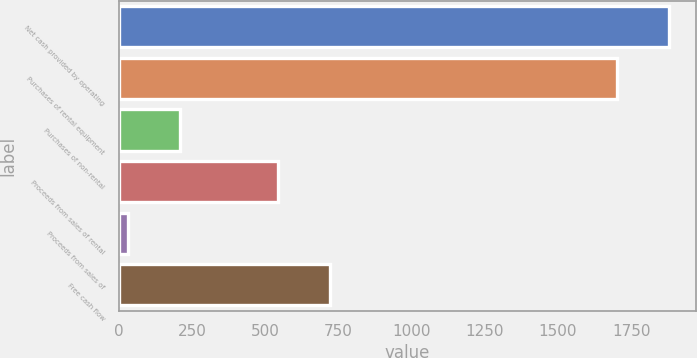<chart> <loc_0><loc_0><loc_500><loc_500><bar_chart><fcel>Net cash provided by operating<fcel>Purchases of rental equipment<fcel>Purchases of non-rental<fcel>Proceeds from sales of rental<fcel>Proceeds from sales of<fcel>Free cash flow<nl><fcel>1877.8<fcel>1701<fcel>209.8<fcel>544<fcel>33<fcel>720.8<nl></chart> 